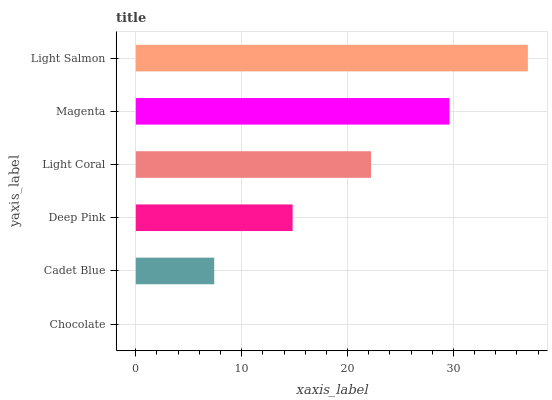Is Chocolate the minimum?
Answer yes or no. Yes. Is Light Salmon the maximum?
Answer yes or no. Yes. Is Cadet Blue the minimum?
Answer yes or no. No. Is Cadet Blue the maximum?
Answer yes or no. No. Is Cadet Blue greater than Chocolate?
Answer yes or no. Yes. Is Chocolate less than Cadet Blue?
Answer yes or no. Yes. Is Chocolate greater than Cadet Blue?
Answer yes or no. No. Is Cadet Blue less than Chocolate?
Answer yes or no. No. Is Light Coral the high median?
Answer yes or no. Yes. Is Deep Pink the low median?
Answer yes or no. Yes. Is Deep Pink the high median?
Answer yes or no. No. Is Light Salmon the low median?
Answer yes or no. No. 